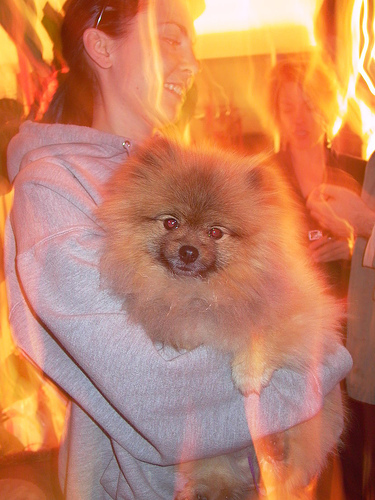<image>
Can you confirm if the flame effects is on the dog? Yes. Looking at the image, I can see the flame effects is positioned on top of the dog, with the dog providing support. Is there a dog next to the woman? Yes. The dog is positioned adjacent to the woman, located nearby in the same general area. 